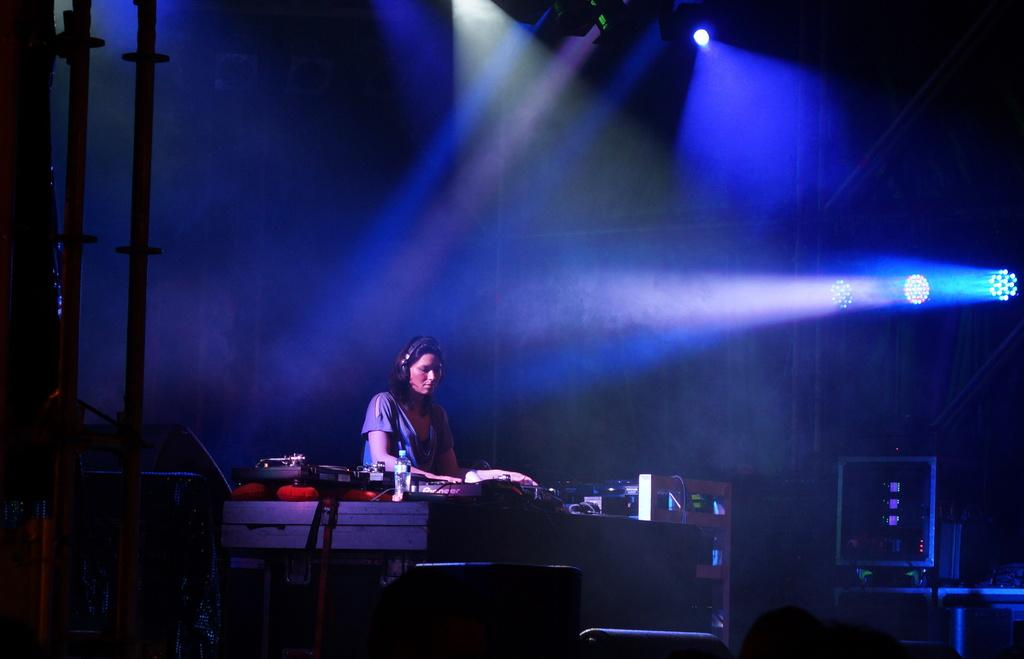Who is present in the image? There is a woman in the image. What else can be seen in the image besides the woman? There are equipment and rods in the image. What can be seen in the background of the image? There are lights in the background of the image. How would you describe the lighting in the image? The image appears to be somewhat dark. What type of oil can be seen dripping from the woman's tongue in the image? There is no oil or tongue present in the image; it features a woman, equipment, rods, and lights. 